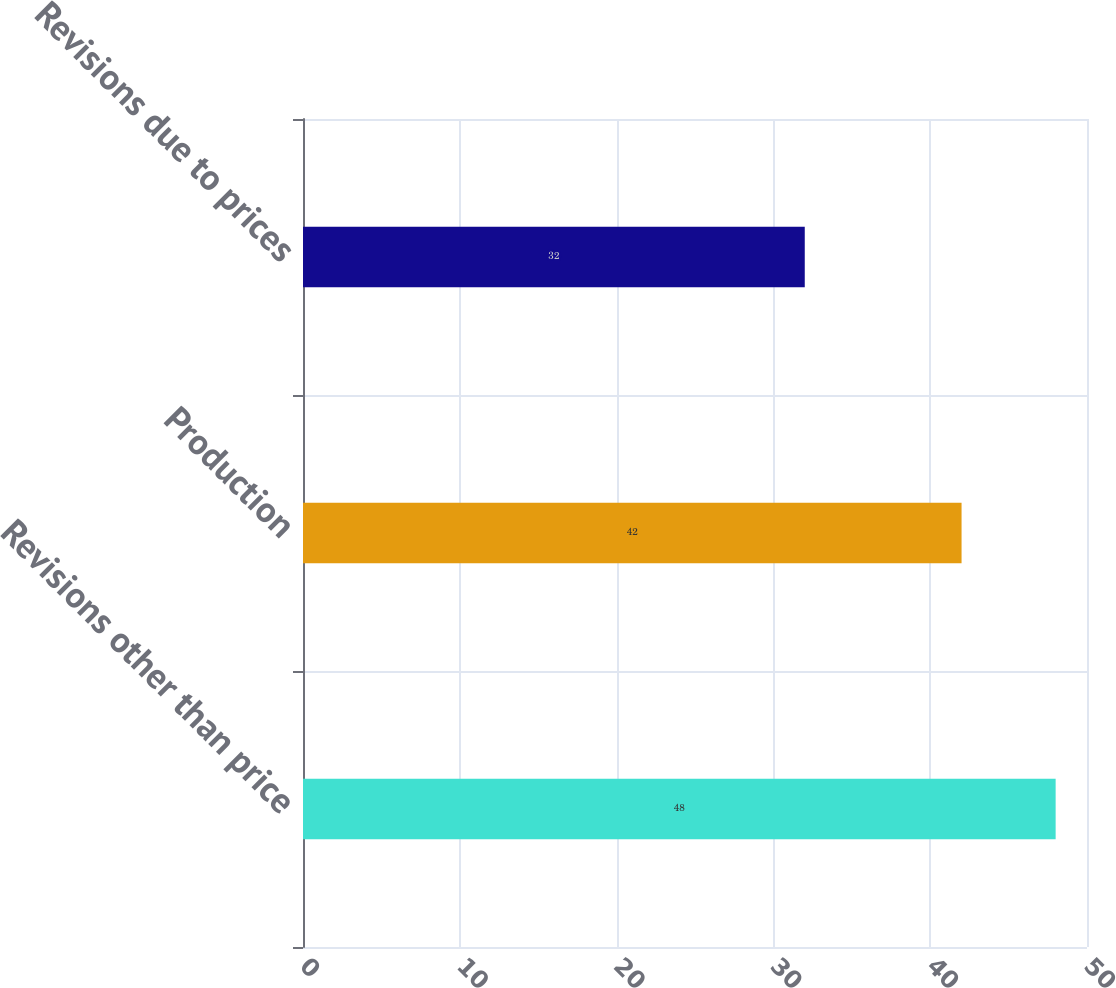Convert chart. <chart><loc_0><loc_0><loc_500><loc_500><bar_chart><fcel>Revisions other than price<fcel>Production<fcel>Revisions due to prices<nl><fcel>48<fcel>42<fcel>32<nl></chart> 